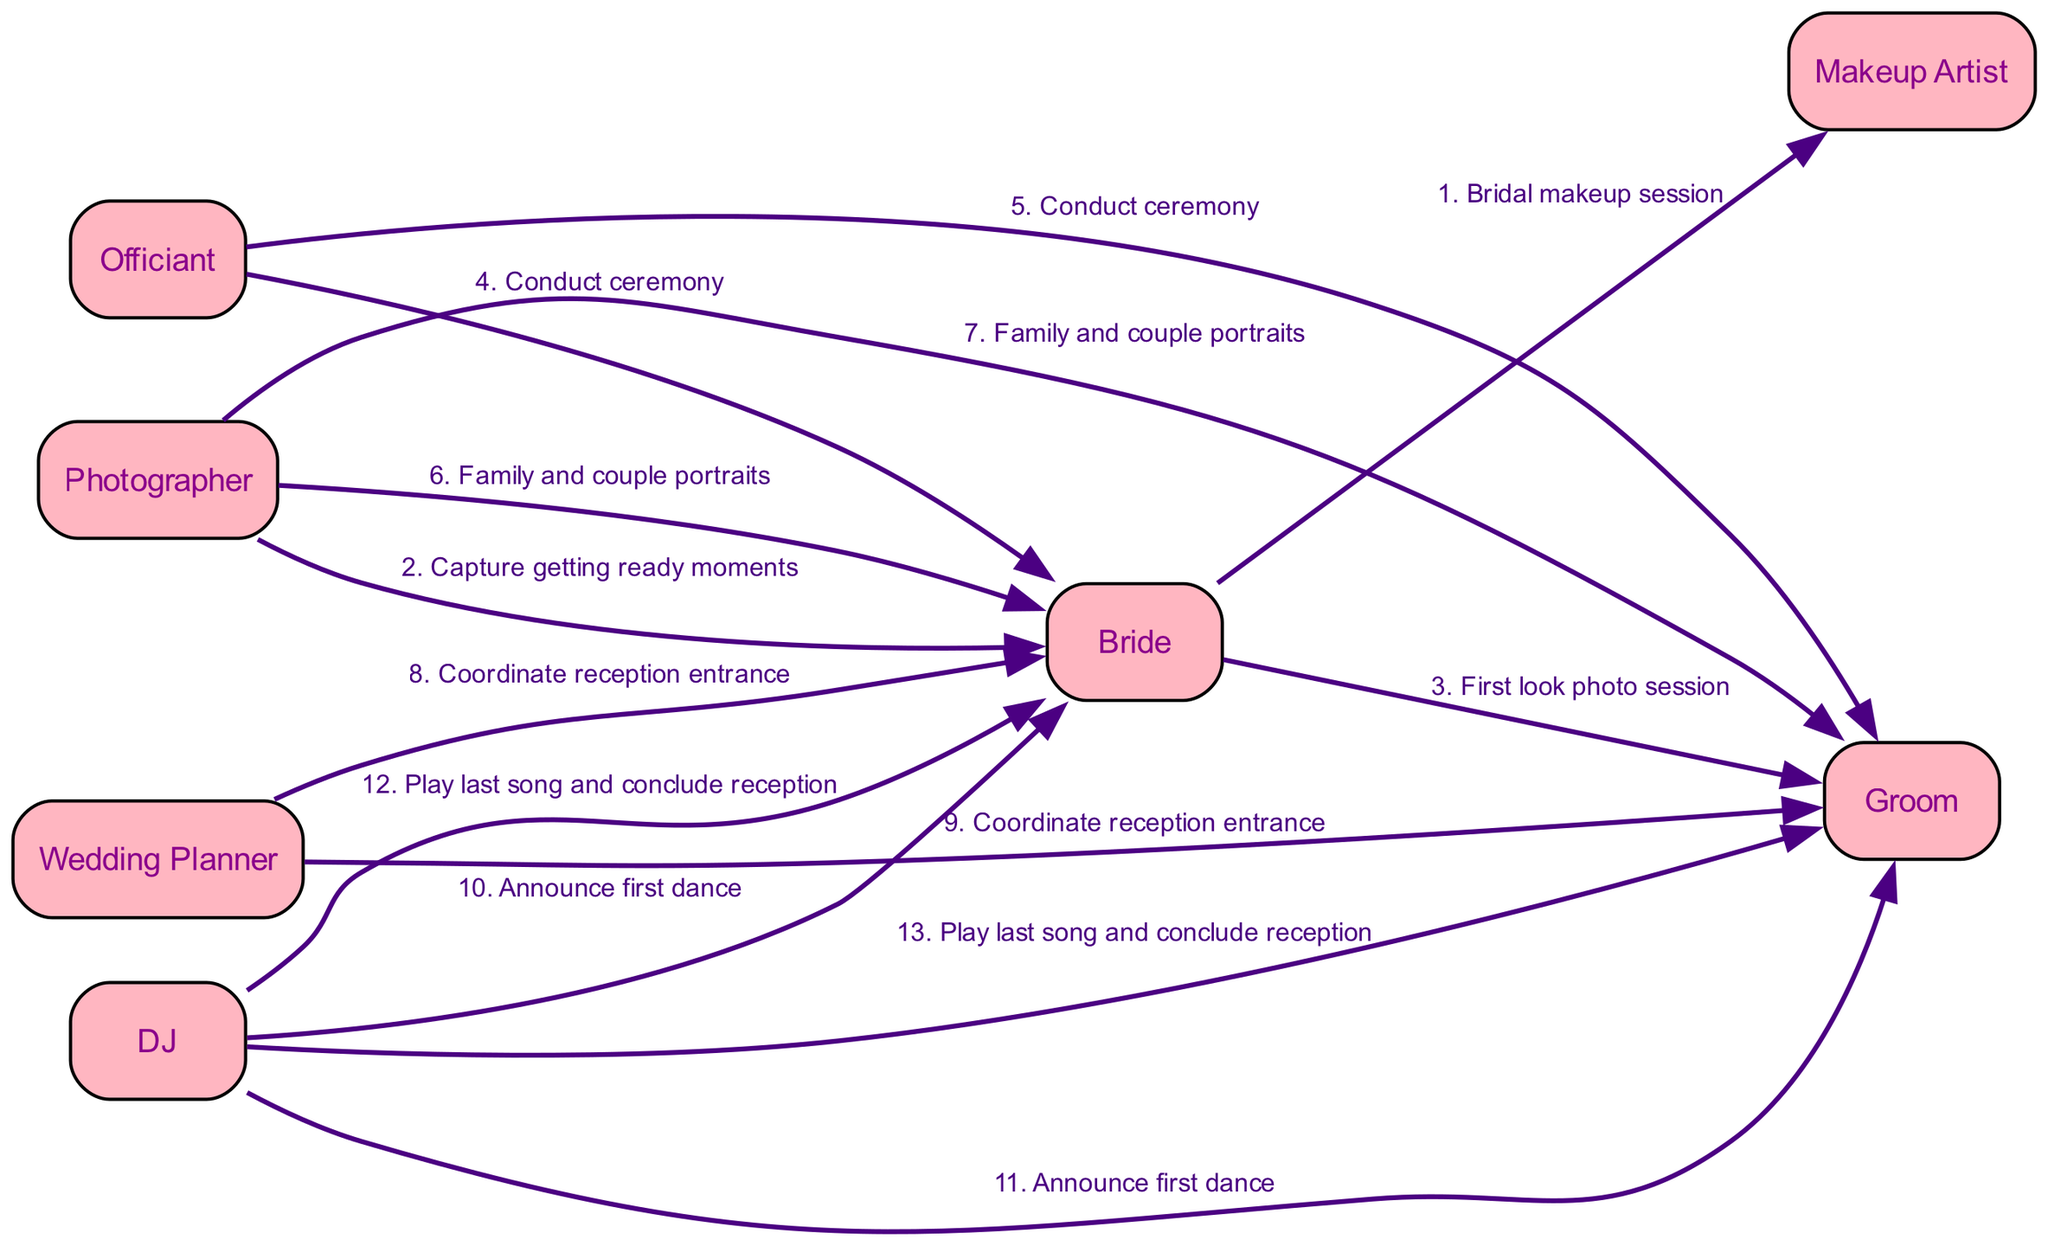What is the first action in the sequence? The first action listed in the sequence is "Bridal makeup session," which is initiated by the Bride towards the Makeup Artist.
Answer: Bridal makeup session How many actors are involved in the wedding day sequence? By counting the different actors listed, there are 7 unique actors involved: Bride, Groom, Makeup Artist, Photographer, Officiant, Wedding Planner, and DJ.
Answer: 7 Who conducts the ceremony for both Bride and Groom? The Officiant is responsible for conducting the ceremony for both the Bride and the Groom, as indicated in the sequence.
Answer: Officiant What is the last action in the sequence? The last action in the sequence is "Play last song and conclude reception," performed by the DJ for both the Bride and Groom.
Answer: Play last song and conclude reception Which actors are involved in the first look photo session? The first look photo session involves just two actors: the Bride and the Groom, specially focused on capturing their initial moment together.
Answer: Bride, Groom How many actions are performed by the Photographer? The Photographer is involved in 3 distinct actions: capturing getting ready moments, family and couple portraits for the Bride, and family and couple portraits for the Groom.
Answer: 3 Which actor is responsible for coordinating the reception entrance? The Wedding Planner is responsible for coordinating the reception entrance for both the Bride and Groom, as shown in the diagram.
Answer: Wedding Planner What is the action performed by the DJ after announcing the first dance? After announcing the first dance, the DJ plays the last song and concludes the reception, which is the final action he takes according to the sequence.
Answer: Play last song and conclude reception 